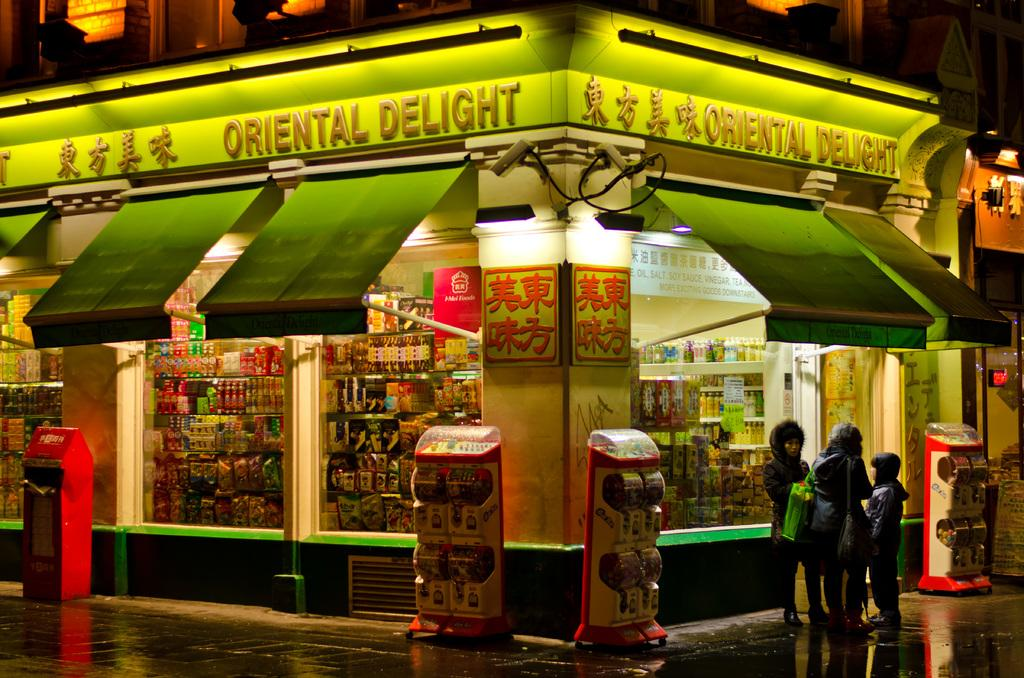<image>
Write a terse but informative summary of the picture. Corner store with foods and beverages on display named Oriental Delight. 